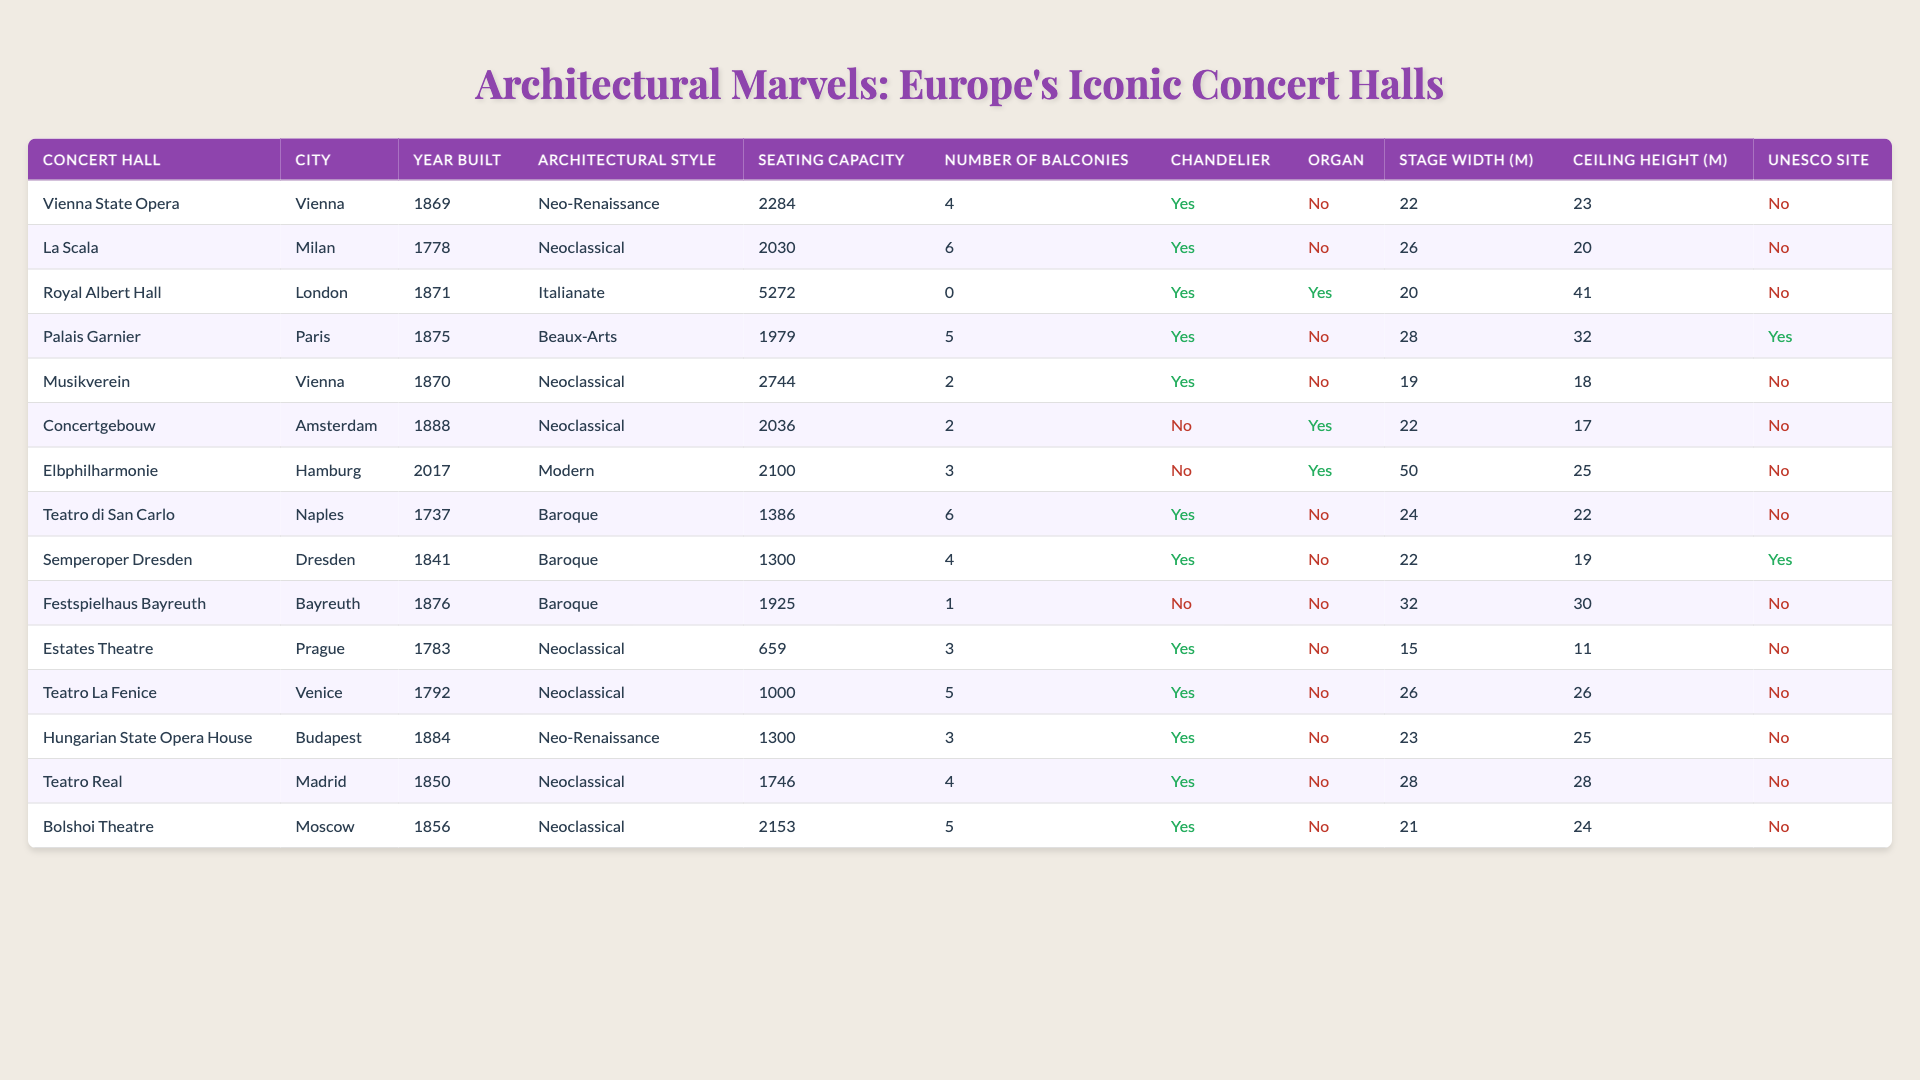What is the seating capacity of the Royal Albert Hall? The Royal Albert Hall has a seating capacity entry of 5272.
Answer: 5272 Which concert hall was built in 2017? The Elbphilharmonie is the only concert hall on the list that was built in 2017.
Answer: Elbphilharmonie How many concert halls have a chandelier present? By counting the entries marked as "Yes" for the chandelier column, there are 10 concert halls with chandeliers present.
Answer: 10 What is the architectural style of the Palais Garnier? The architectural style of the Palais Garnier, as listed, is Beaux-Arts.
Answer: Beaux-Arts Which concert hall has the highest ceiling height? The Royal Albert Hall has the highest ceiling height listed at 41 meters.
Answer: Royal Albert Hall Is the Teatro di San Carlo a UNESCO World Heritage site? The Teatro di San Carlo is not listed as a UNESCO World Heritage Site, as indicated by the "No" entry.
Answer: No How many balconies does the Vienna State Opera have compared to the Semperoper Dresden? The Vienna State Opera has 4 balconies, while the Semperoper Dresden has 4 balconies as well, resulting in them having an equal number of balconies.
Answer: They both have 4 balconies Which concert hall has the largest stage width? The Elbphilharmonie has the largest stage width at 50 meters.
Answer: Elbphilharmonie What is the average seating capacity of the concert halls in Vienna? The concert halls in Vienna are the Vienna State Opera (2284), Musikverein (2744), and the total capacity is 5028 for these two halls. Dividing by 2 gives an average of 2514.
Answer: 2514 Which has more balconies, La Scala or Teatro La Fenice? La Scala has 6 balconies while Teatro La Fenice has 5 balconies, indicating La Scala has more.
Answer: La Scala What percentage of the concert halls listed have an organ present? There are 3 concert halls with an organ present out of 15 total concert halls, making it 20%.
Answer: 20% 